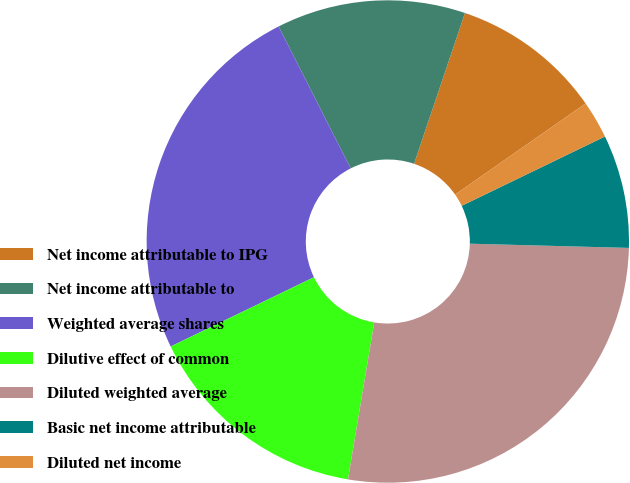Convert chart to OTSL. <chart><loc_0><loc_0><loc_500><loc_500><pie_chart><fcel>Net income attributable to IPG<fcel>Net income attributable to<fcel>Weighted average shares<fcel>Dilutive effect of common<fcel>Diluted weighted average<fcel>Basic net income attributable<fcel>Diluted net income<nl><fcel>10.12%<fcel>12.66%<fcel>24.69%<fcel>15.19%<fcel>27.22%<fcel>7.59%<fcel>2.53%<nl></chart> 